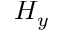Convert formula to latex. <formula><loc_0><loc_0><loc_500><loc_500>H _ { y }</formula> 